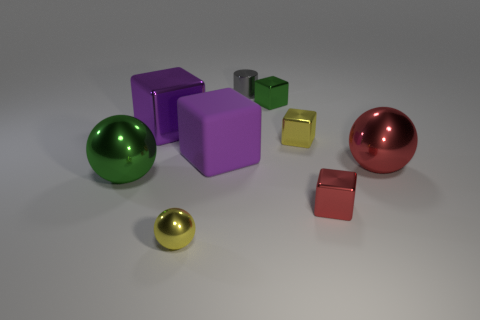Subtract all big metal balls. How many balls are left? 1 Subtract all purple cubes. How many cubes are left? 3 Add 1 small things. How many objects exist? 10 Subtract all yellow cubes. Subtract all gray cylinders. How many cubes are left? 4 Subtract all spheres. How many objects are left? 6 Subtract 0 brown cubes. How many objects are left? 9 Subtract all gray matte objects. Subtract all tiny cylinders. How many objects are left? 8 Add 4 large rubber blocks. How many large rubber blocks are left? 5 Add 5 spheres. How many spheres exist? 8 